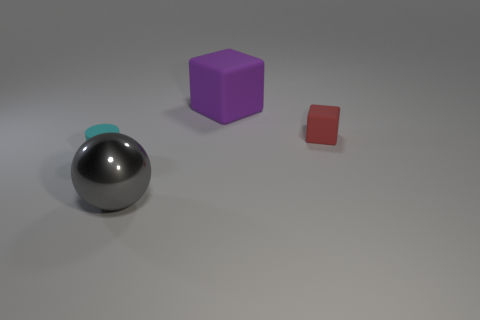Are there the same number of large gray things on the left side of the metallic ball and tiny red rubber cubes that are left of the big rubber thing?
Give a very brief answer. Yes. Do the tiny rubber object that is on the right side of the tiny cyan object and the purple thing have the same shape?
Make the answer very short. Yes. Is there any other thing that has the same material as the big gray object?
Your answer should be compact. No. There is a ball; is its size the same as the purple thing that is behind the cyan matte cylinder?
Offer a terse response. Yes. What number of other things are the same color as the small matte block?
Offer a very short reply. 0. Are there any cyan objects behind the large rubber thing?
Offer a terse response. No. What number of objects are either matte blocks or cubes that are in front of the big purple block?
Your answer should be compact. 2. There is a thing that is in front of the cyan object; are there any purple matte objects that are behind it?
Provide a succinct answer. Yes. The tiny thing that is to the right of the metallic ball that is in front of the tiny matte thing left of the gray thing is what shape?
Ensure brevity in your answer.  Cube. What is the color of the rubber object that is both left of the small matte cube and behind the cyan rubber cylinder?
Your response must be concise. Purple. 